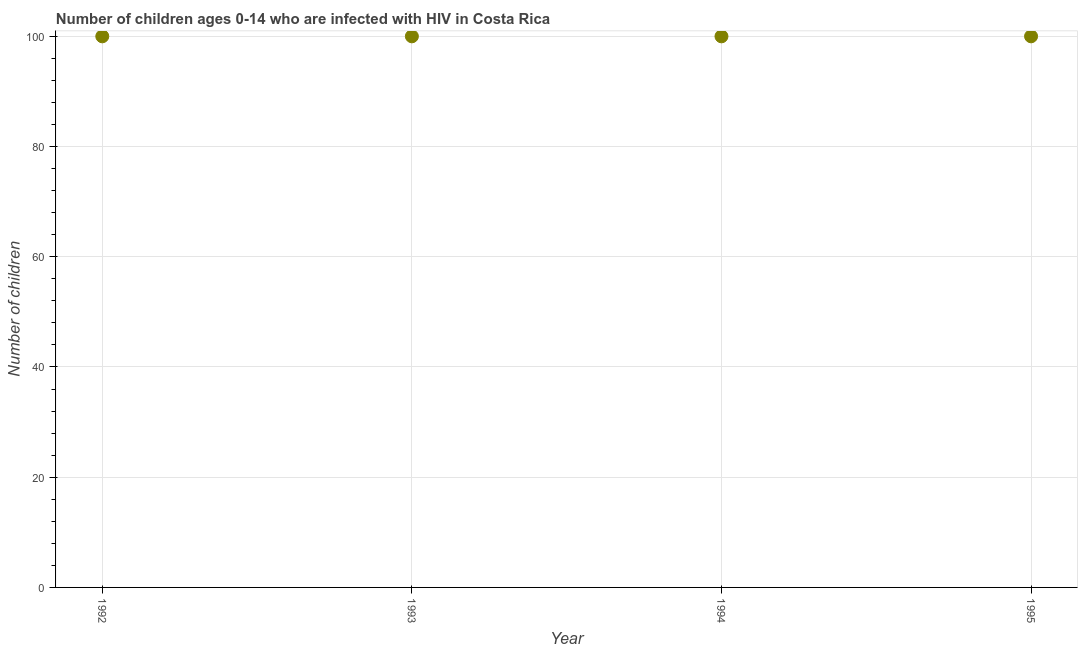What is the number of children living with hiv in 1993?
Your answer should be compact. 100. Across all years, what is the maximum number of children living with hiv?
Your answer should be very brief. 100. Across all years, what is the minimum number of children living with hiv?
Your answer should be compact. 100. What is the sum of the number of children living with hiv?
Your response must be concise. 400. Is the number of children living with hiv in 1993 less than that in 1995?
Make the answer very short. No. Is the difference between the number of children living with hiv in 1992 and 1993 greater than the difference between any two years?
Give a very brief answer. Yes. Is the sum of the number of children living with hiv in 1993 and 1995 greater than the maximum number of children living with hiv across all years?
Your answer should be compact. Yes. What is the difference between the highest and the lowest number of children living with hiv?
Offer a terse response. 0. How many years are there in the graph?
Your response must be concise. 4. What is the difference between two consecutive major ticks on the Y-axis?
Your answer should be very brief. 20. Are the values on the major ticks of Y-axis written in scientific E-notation?
Your response must be concise. No. What is the title of the graph?
Your answer should be compact. Number of children ages 0-14 who are infected with HIV in Costa Rica. What is the label or title of the X-axis?
Make the answer very short. Year. What is the label or title of the Y-axis?
Ensure brevity in your answer.  Number of children. What is the Number of children in 1992?
Your answer should be very brief. 100. What is the Number of children in 1994?
Provide a short and direct response. 100. What is the difference between the Number of children in 1992 and 1994?
Your answer should be compact. 0. What is the difference between the Number of children in 1992 and 1995?
Offer a terse response. 0. What is the difference between the Number of children in 1993 and 1995?
Ensure brevity in your answer.  0. What is the ratio of the Number of children in 1992 to that in 1993?
Provide a short and direct response. 1. What is the ratio of the Number of children in 1992 to that in 1994?
Make the answer very short. 1. What is the ratio of the Number of children in 1992 to that in 1995?
Give a very brief answer. 1. What is the ratio of the Number of children in 1993 to that in 1994?
Offer a terse response. 1. 